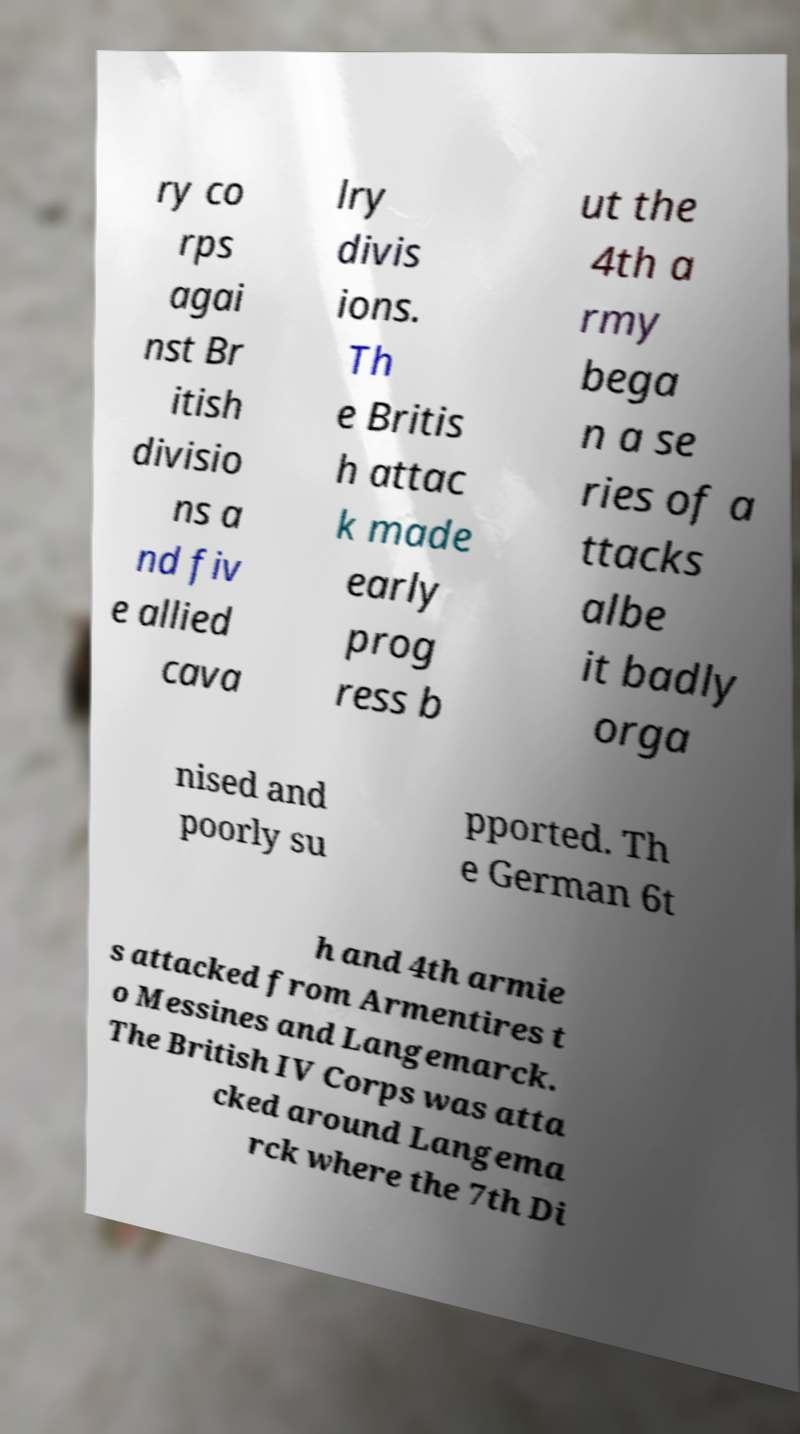Can you accurately transcribe the text from the provided image for me? ry co rps agai nst Br itish divisio ns a nd fiv e allied cava lry divis ions. Th e Britis h attac k made early prog ress b ut the 4th a rmy bega n a se ries of a ttacks albe it badly orga nised and poorly su pported. Th e German 6t h and 4th armie s attacked from Armentires t o Messines and Langemarck. The British IV Corps was atta cked around Langema rck where the 7th Di 